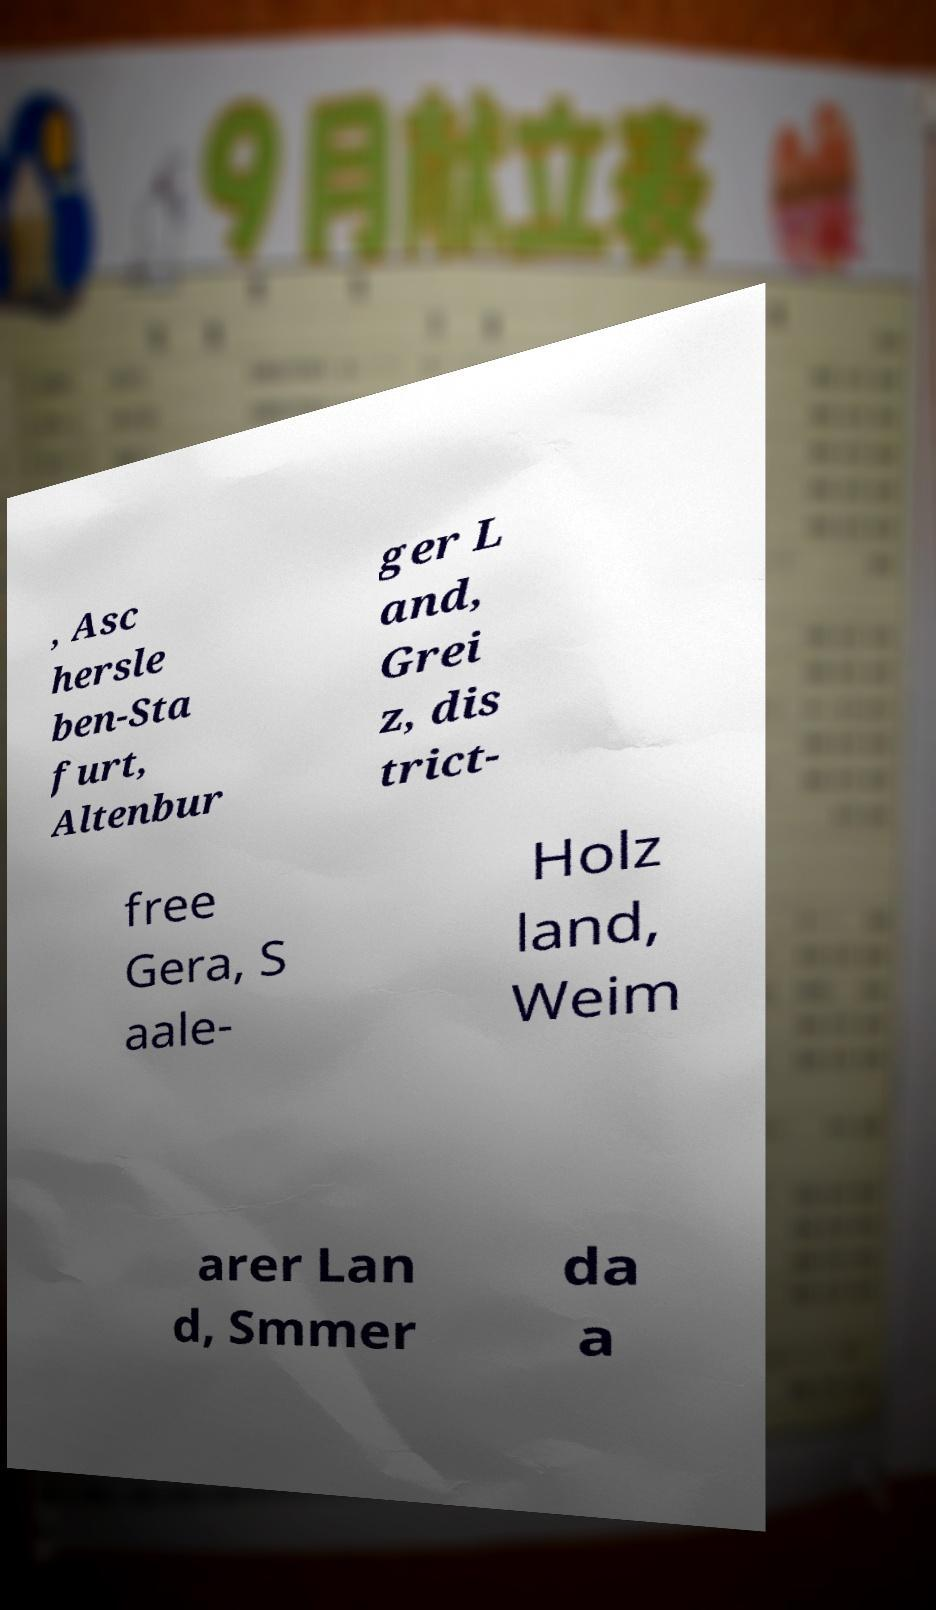What messages or text are displayed in this image? I need them in a readable, typed format. , Asc hersle ben-Sta furt, Altenbur ger L and, Grei z, dis trict- free Gera, S aale- Holz land, Weim arer Lan d, Smmer da a 